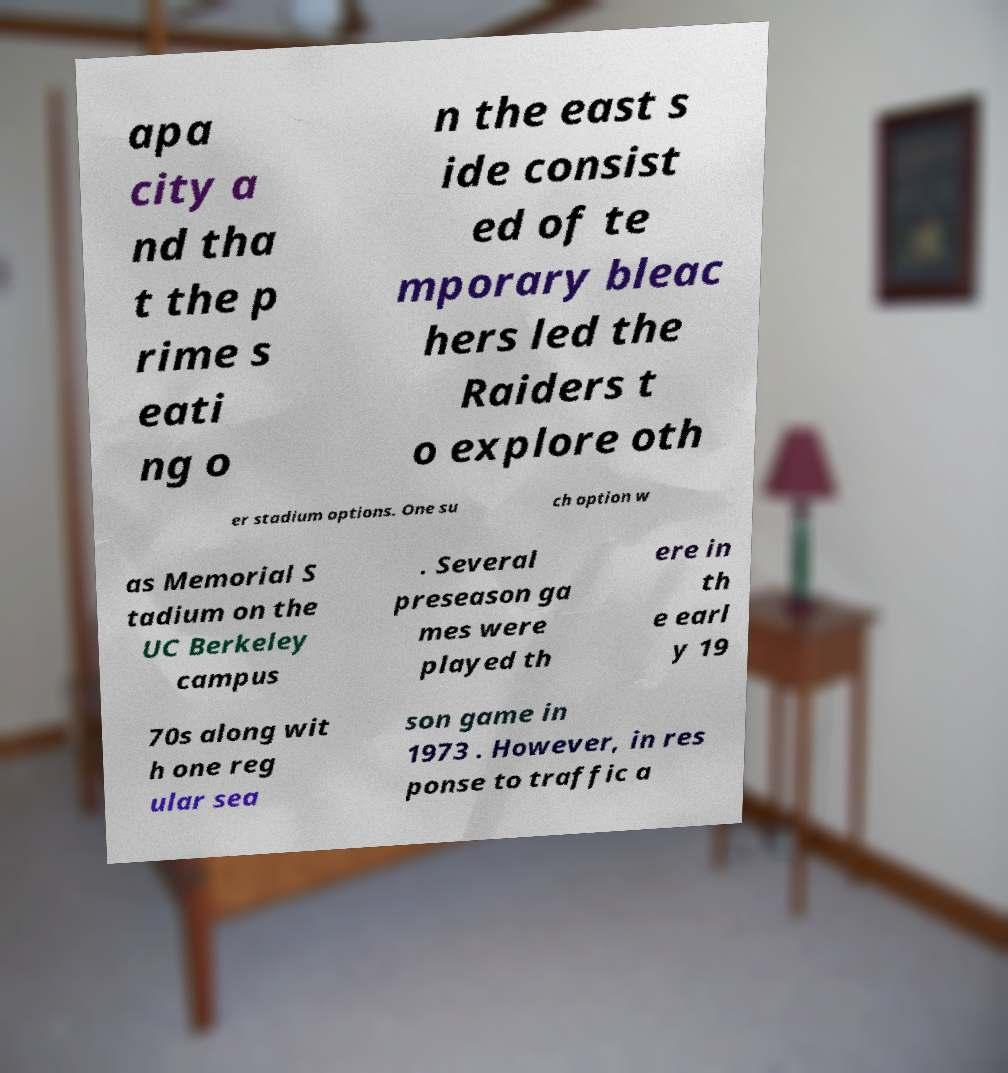Could you assist in decoding the text presented in this image and type it out clearly? apa city a nd tha t the p rime s eati ng o n the east s ide consist ed of te mporary bleac hers led the Raiders t o explore oth er stadium options. One su ch option w as Memorial S tadium on the UC Berkeley campus . Several preseason ga mes were played th ere in th e earl y 19 70s along wit h one reg ular sea son game in 1973 . However, in res ponse to traffic a 